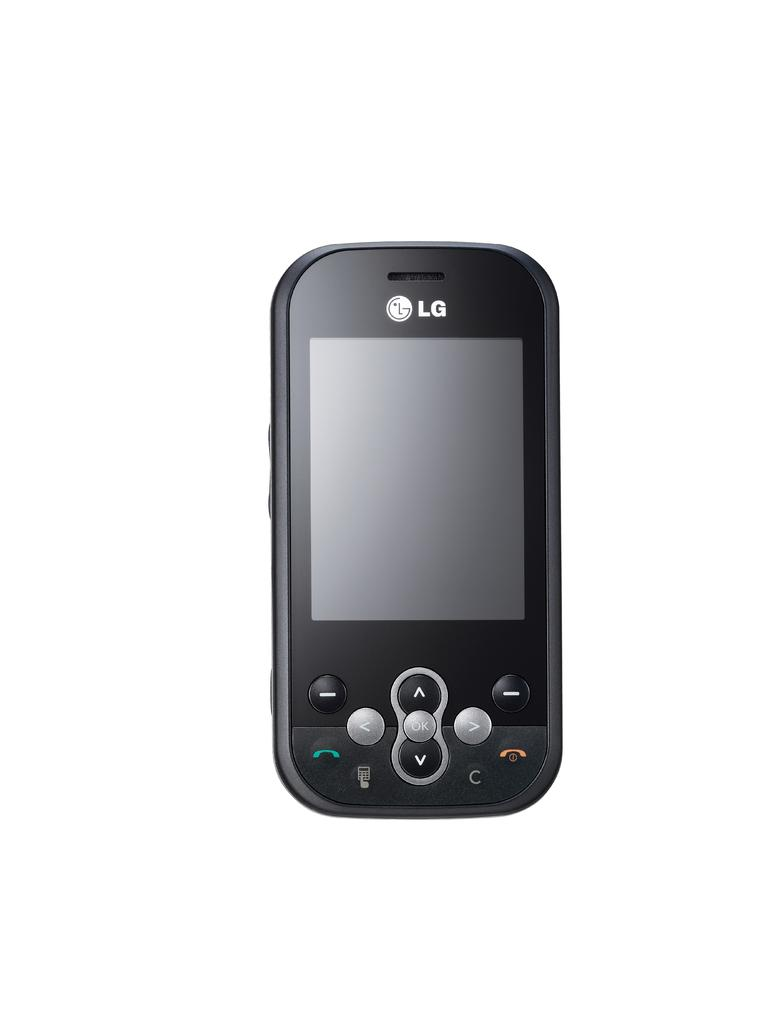<image>
Give a short and clear explanation of the subsequent image. An LG phone sits with the power off and the screen dark. 